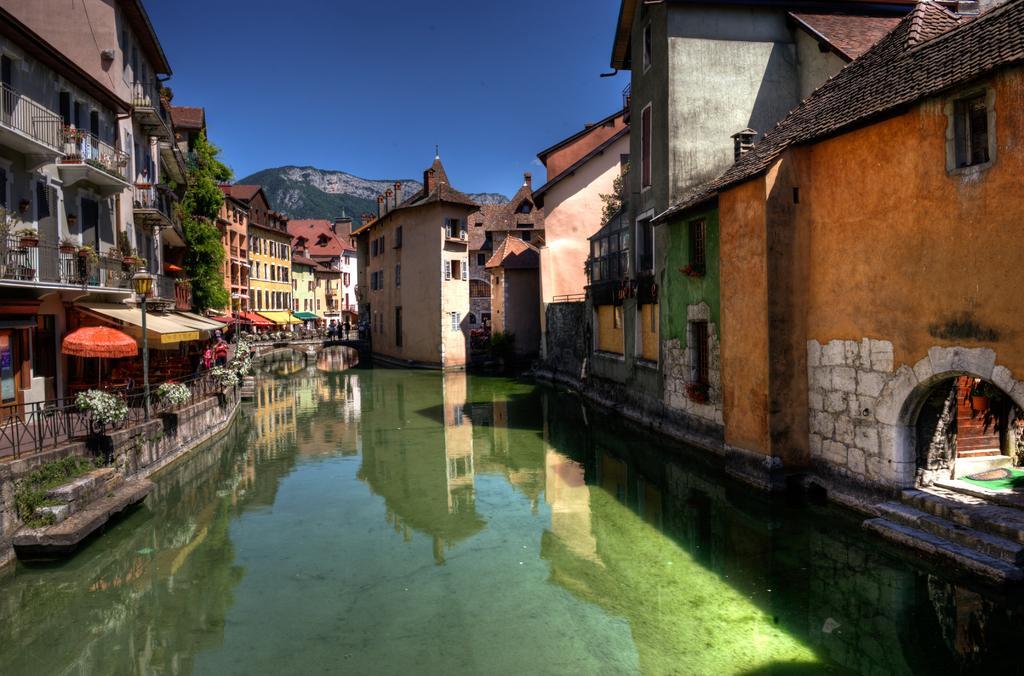In one or two sentences, can you explain what this image depicts? In this image, we can see some buildings, poles, sheds, plants, hills. We can see the fence and some water with the reflection. We can see an umbrella. We can see the sky. 